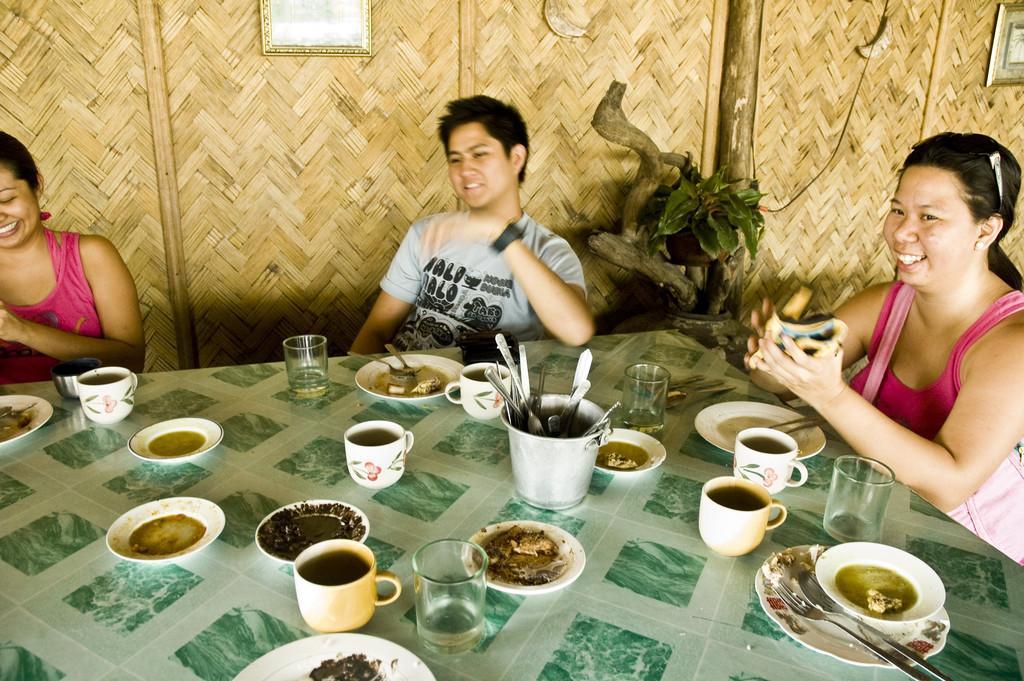In one or two sentences, can you explain what this image depicts? In this image, There is a table which is in green color on that table there are some glasses and cups and there are some plates and there are some people siting on the chairs around the table and in the background there is a yellow color wooden door. 